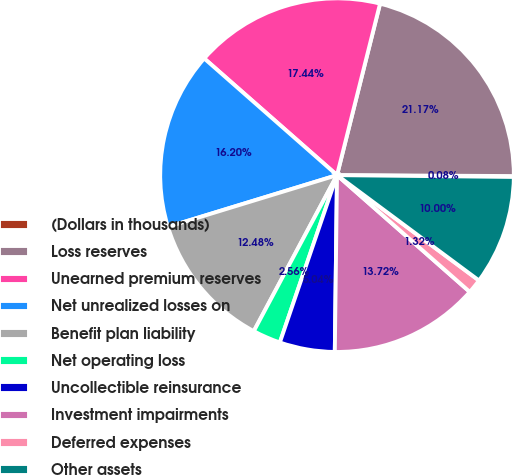Convert chart to OTSL. <chart><loc_0><loc_0><loc_500><loc_500><pie_chart><fcel>(Dollars in thousands)<fcel>Loss reserves<fcel>Unearned premium reserves<fcel>Net unrealized losses on<fcel>Benefit plan liability<fcel>Net operating loss<fcel>Uncollectible reinsurance<fcel>Investment impairments<fcel>Deferred expenses<fcel>Other assets<nl><fcel>0.08%<fcel>21.17%<fcel>17.44%<fcel>16.2%<fcel>12.48%<fcel>2.56%<fcel>5.04%<fcel>13.72%<fcel>1.32%<fcel>10.0%<nl></chart> 